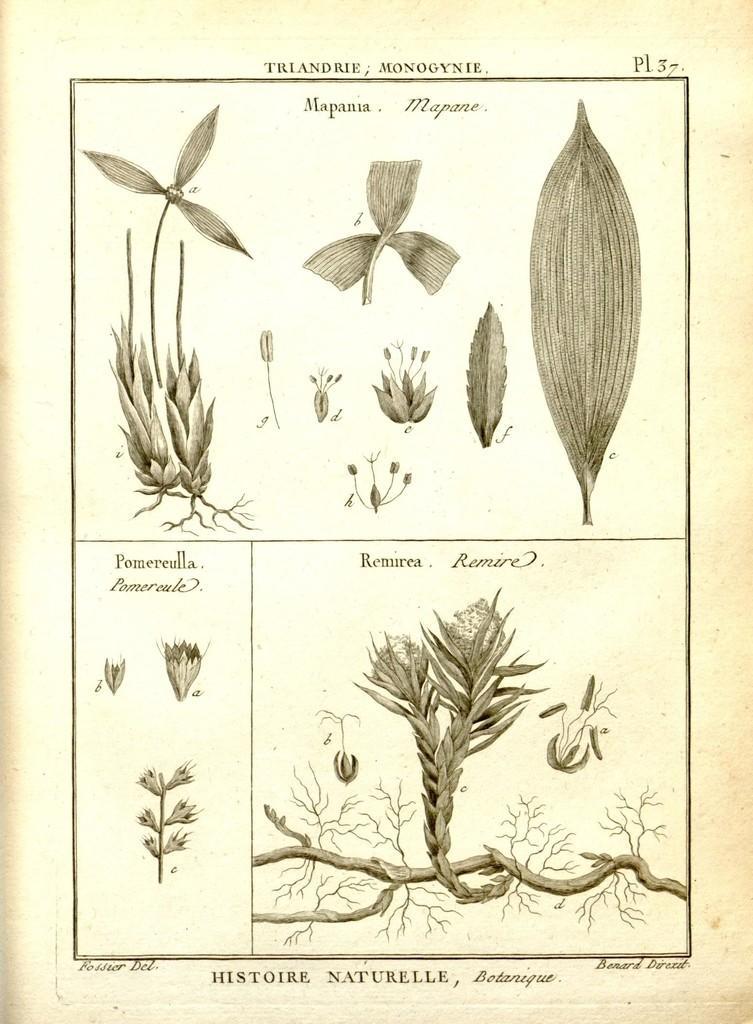Can you describe this image briefly? This is a black and white image, in this we can see some different plants with some text. 